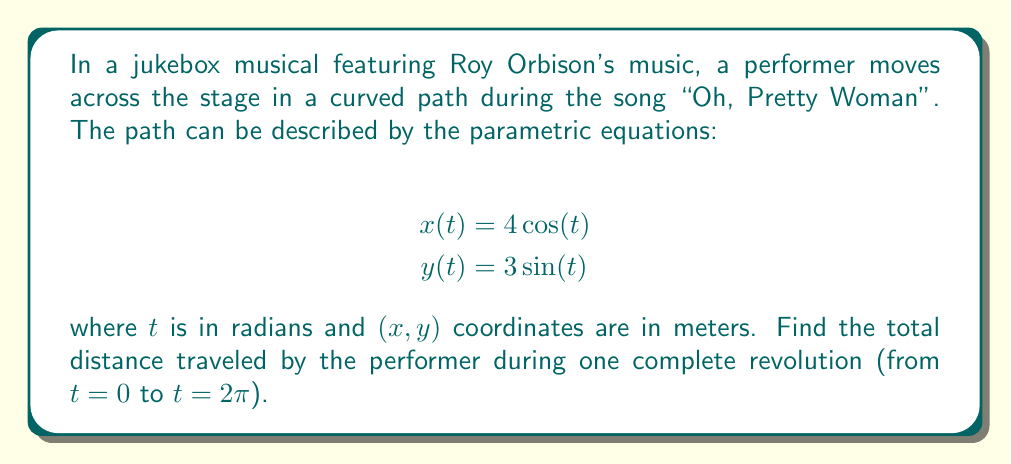Could you help me with this problem? To find the total distance traveled along a parametric curve, we need to use the arc length formula:

$$L = \int_{a}^{b} \sqrt{\left(\frac{dx}{dt}\right)^2 + \left(\frac{dy}{dt}\right)^2} dt$$

Step 1: Find $\frac{dx}{dt}$ and $\frac{dy}{dt}$
$$\frac{dx}{dt} = -4\sin(t)$$
$$\frac{dy}{dt} = 3\cos(t)$$

Step 2: Substitute into the arc length formula
$$L = \int_{0}^{2\pi} \sqrt{(-4\sin(t))^2 + (3\cos(t))^2} dt$$

Step 3: Simplify under the square root
$$L = \int_{0}^{2\pi} \sqrt{16\sin^2(t) + 9\cos^2(t)} dt$$

Step 4: Use the identity $\sin^2(t) + \cos^2(t) = 1$ to simplify further
$$L = \int_{0}^{2\pi} \sqrt{16\sin^2(t) + 9(1-\sin^2(t))} dt$$
$$L = \int_{0}^{2\pi} \sqrt{16\sin^2(t) + 9 - 9\sin^2(t)} dt$$
$$L = \int_{0}^{2\pi} \sqrt{7\sin^2(t) + 9} dt$$

Step 5: Let $u = 7\sin^2(t) + 9$, then $du = 14\sin(t)\cos(t)dt$
$$L = \int_{0}^{2\pi} \sqrt{u} \cdot \frac{du}{14\sin(t)\cos(t)}$$

Step 6: Recognize that this integral doesn't have an elementary antiderivative. We need to use numerical methods or elliptic integrals to evaluate it. Using a numerical integration method, we get:

$$L \approx 22.1038$$

Therefore, the total distance traveled by the performer is approximately 22.1038 meters.
Answer: The total distance traveled by the performer during one complete revolution is approximately 22.1038 meters. 